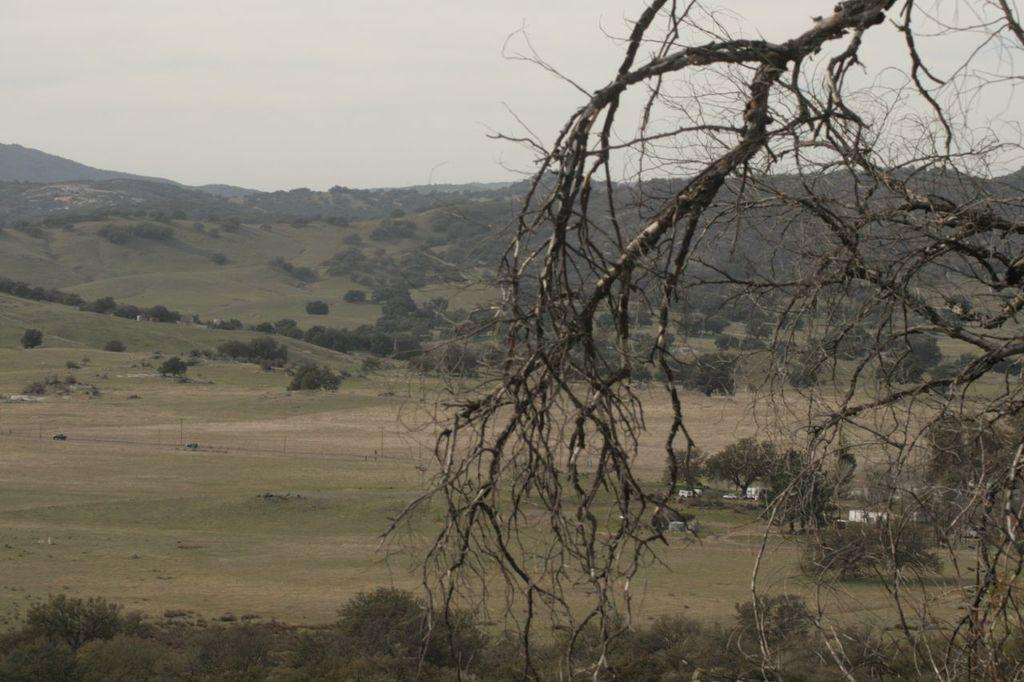What type of vegetation can be seen in the image? There are trees and plants in the image. What natural features are visible in the image? There are mountains in the image. What is visible in the sky in the image? The sky is visible in the image. How many cherries are hanging from the trees in the image? There are no cherries visible in the image; only trees and plants are present. What type of reward is being given to the students during recess in the image? There is no reference to students, recess, or rewards in the image; it features trees, plants, mountains, and the sky. 